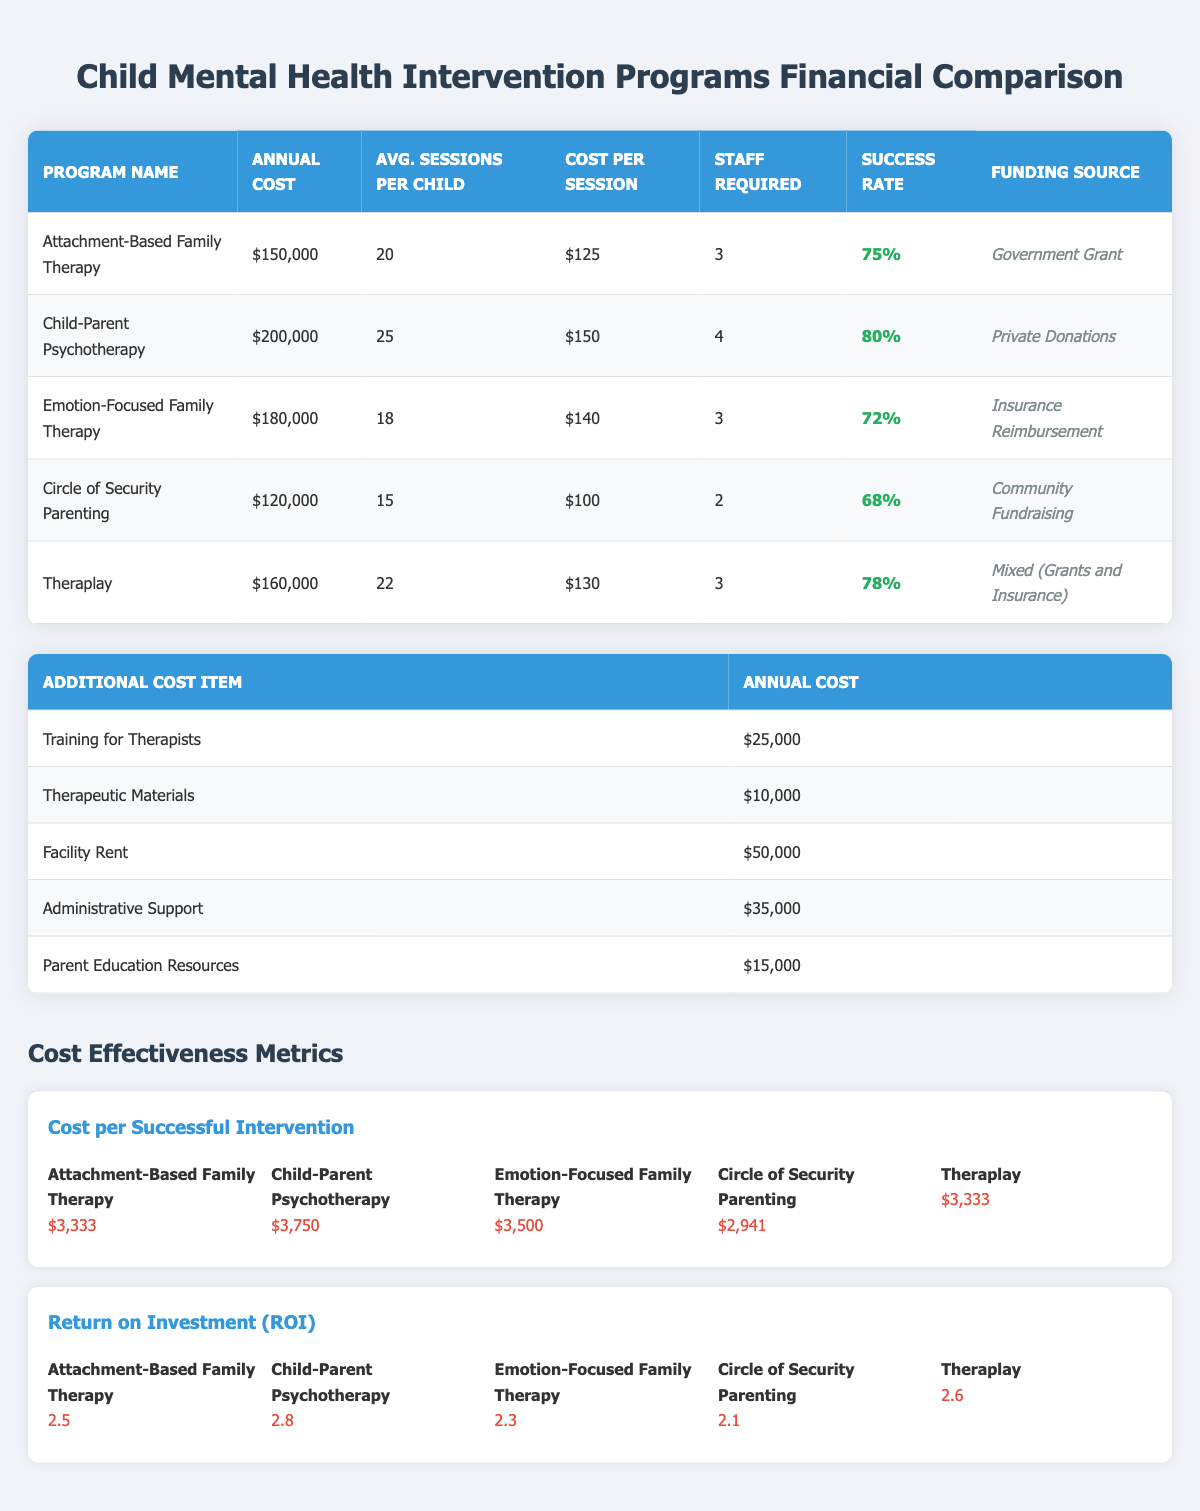What is the cost per session for Child-Parent Psychotherapy? The table lists the cost per session for each program. For Child-Parent Psychotherapy, it is specified as $150.
Answer: $150 Which program has the highest success rate? The success rates of each program are listed. Reviewing the success rates shows that Child-Parent Psychotherapy has the highest success rate at 80%.
Answer: 80% What is the total annual cost for all the intervention programs combined? The annual costs for each program are $150,000, $200,000, $180,000, $120,000, and $160,000. Adding these amounts gives a total of $150,000 + $200,000 + $180,000 + $120,000 + $160,000 = $910,000 total annual cost.
Answer: $910,000 Is the annual cost of Circle of Security Parenting less than the annual cost of Emotion-Focused Family Therapy? The annual cost for Circle of Security Parenting is $120,000 and for Emotion-Focused Family Therapy, it is $180,000. Since $120,000 is less than $180,000, the statement is true.
Answer: Yes What is the average cost per successful intervention for the programs listed? The cost per successful intervention for each program is $3,333, $3,750, $3,500, $2,941, and $3,333. Adding these values gives $3,333 + $3,750 + $3,500 + $2,941 + $3,333 = $16,857, and dividing by 5 programs provides an average of $16,857 / 5 = $3,371.40.
Answer: $3,371.40 Which program has the lowest Return on Investment (ROI)? The ROI values for each program are provided: 2.5, 2.8, 2.3, 2.1, and 2.6. The lowest ROI is found by comparing these values, which shows Circle of Security Parenting with an ROI of 2.1.
Answer: 2.1 Find the total number of staff required for all programs combined. Staff required per program are 3, 4, 3, 2, and 3. Adding these gives a total staff requirement of 3 + 4 + 3 + 2 + 3 = 15 staff members.
Answer: 15 Does Theraplay have a higher annual cost than Attachment-Based Family Therapy? The annual cost for Theraplay is $160,000 and for Attachment-Based Family Therapy, it is $150,000. Since $160,000 is greater than $150,000, the answer is true.
Answer: Yes 